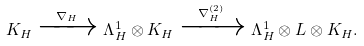<formula> <loc_0><loc_0><loc_500><loc_500>K _ { H } \xrightarrow { \, \nabla _ { H } \, } \Lambda _ { H } ^ { 1 } \otimes K _ { H } \xrightarrow { \, \nabla _ { H } ^ { ( 2 ) } \, } \Lambda _ { H } ^ { 1 } \otimes L \otimes K _ { H } .</formula> 